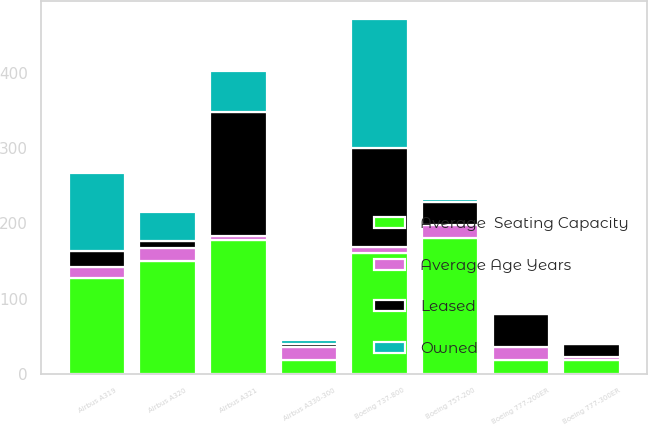Convert chart to OTSL. <chart><loc_0><loc_0><loc_500><loc_500><stacked_bar_chart><ecel><fcel>Airbus A319<fcel>Airbus A320<fcel>Airbus A321<fcel>Airbus A330-300<fcel>Boeing 737-800<fcel>Boeing 757-200<fcel>Boeing 777-200ER<fcel>Boeing 777-300ER<nl><fcel>Average  Seating Capacity<fcel>128<fcel>150<fcel>178<fcel>18.1<fcel>160<fcel>180<fcel>18.1<fcel>18.1<nl><fcel>Average Age Years<fcel>13.8<fcel>16.7<fcel>5.4<fcel>17.4<fcel>8.1<fcel>18.1<fcel>17<fcel>3.8<nl><fcel>Leased<fcel>21<fcel>10<fcel>165<fcel>4<fcel>132<fcel>31<fcel>44<fcel>18<nl><fcel>Owned<fcel>104<fcel>38<fcel>54<fcel>5<fcel>172<fcel>3<fcel>3<fcel>2<nl></chart> 